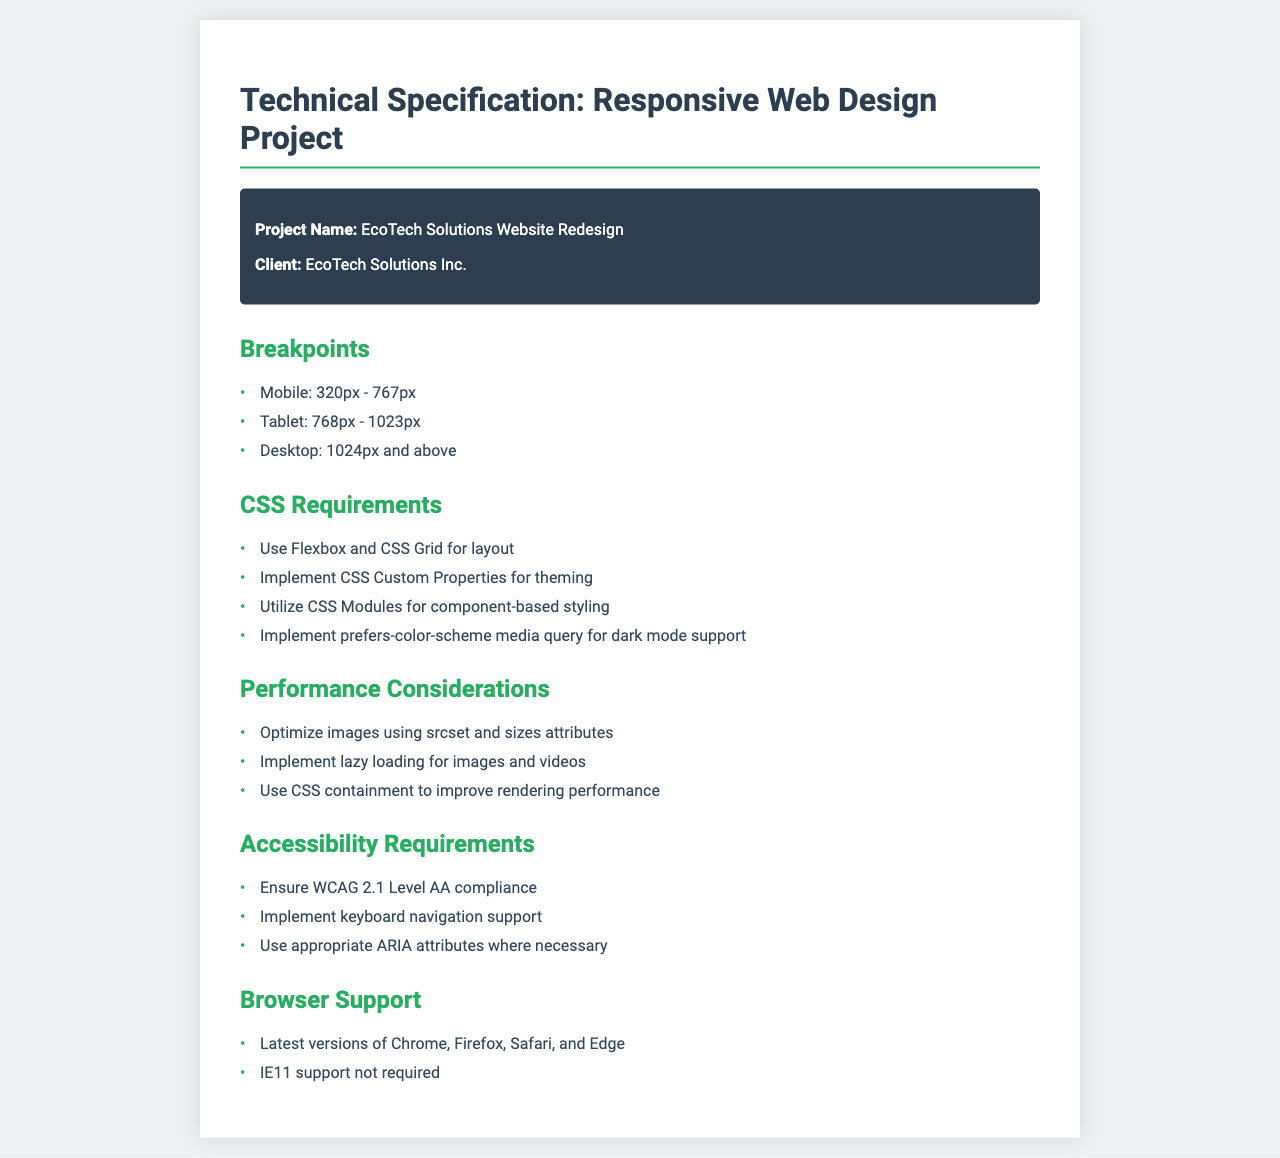what is the project name? The project name is clearly stated in the document within the project information section.
Answer: EcoTech Solutions Website Redesign who is the client? The client is mentioned in the same project information section as the project name.
Answer: EcoTech Solutions Inc what are the breakpoints for mobile design? The breakpoints are listed in the breakpoints section of the document; mobile is specifically outlined.
Answer: 320px - 767px which CSS layout techniques are required? The CSS requirements section outlines specific techniques that need to be used for layout.
Answer: Flexbox and CSS Grid what is the minimum width for tablet design? The breakpoints mention specific widths for tablet design, allowing for easy retrieval of this information.
Answer: 768px what level of accessibility compliance is required? The accessibility requirements section specifies the compliance level that needs to be met.
Answer: WCAG 2.1 Level AA is Internet Explorer 11 supported? The browser support section clearly states the support status for Internet Explorer 11.
Answer: not required what is the maximum width for the fax container? The maximum width is specified in the CSS styling section of the document, defining layout limits.
Answer: 800px 